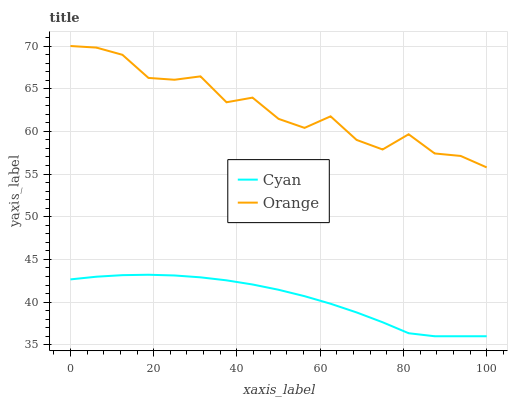Does Cyan have the maximum area under the curve?
Answer yes or no. No. Is Cyan the roughest?
Answer yes or no. No. Does Cyan have the highest value?
Answer yes or no. No. Is Cyan less than Orange?
Answer yes or no. Yes. Is Orange greater than Cyan?
Answer yes or no. Yes. Does Cyan intersect Orange?
Answer yes or no. No. 